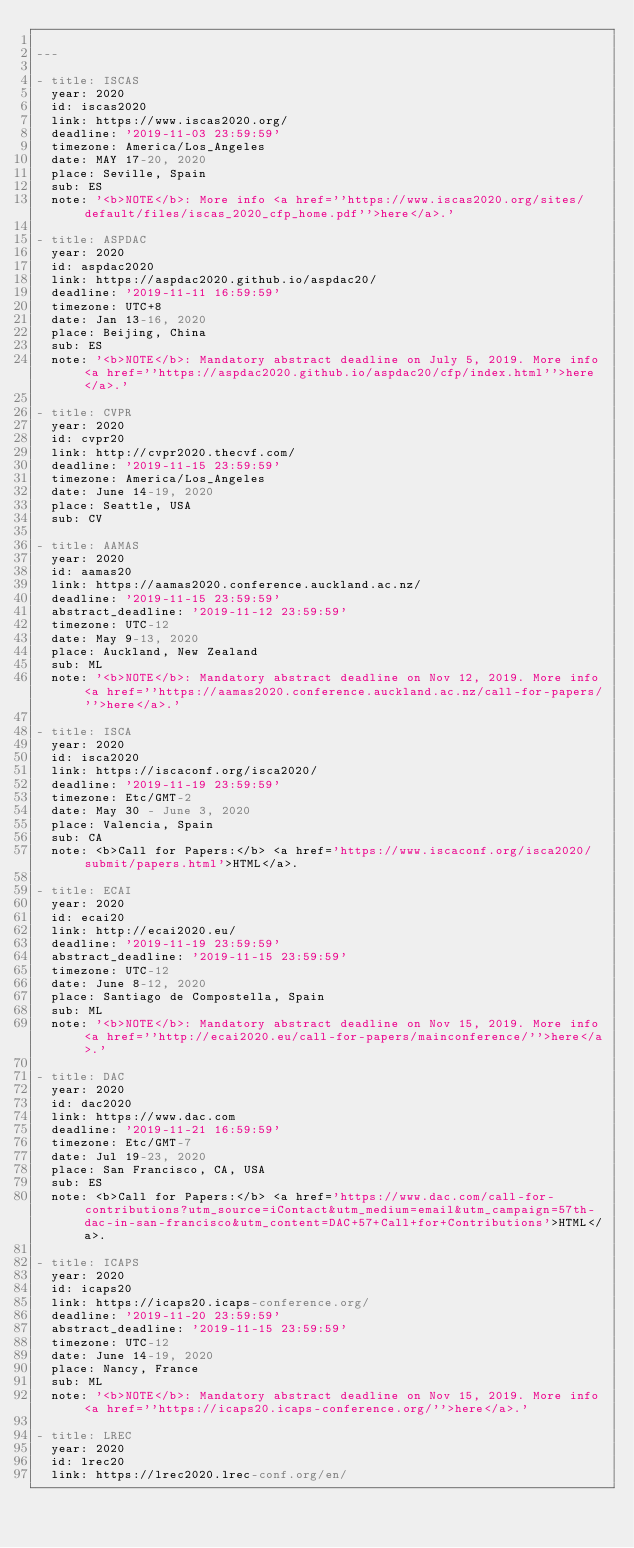Convert code to text. <code><loc_0><loc_0><loc_500><loc_500><_YAML_>
---

- title: ISCAS
  year: 2020
  id: iscas2020
  link: https://www.iscas2020.org/
  deadline: '2019-11-03 23:59:59'
  timezone: America/Los_Angeles
  date: MAY 17-20, 2020
  place: Seville, Spain
  sub: ES
  note: '<b>NOTE</b>: More info <a href=''https://www.iscas2020.org/sites/default/files/iscas_2020_cfp_home.pdf''>here</a>.'

- title: ASPDAC
  year: 2020
  id: aspdac2020
  link: https://aspdac2020.github.io/aspdac20/
  deadline: '2019-11-11 16:59:59'
  timezone: UTC+8
  date: Jan 13-16, 2020
  place: Beijing, China
  sub: ES
  note: '<b>NOTE</b>: Mandatory abstract deadline on July 5, 2019. More info <a href=''https://aspdac2020.github.io/aspdac20/cfp/index.html''>here</a>.'

- title: CVPR
  year: 2020
  id: cvpr20
  link: http://cvpr2020.thecvf.com/
  deadline: '2019-11-15 23:59:59'
  timezone: America/Los_Angeles
  date: June 14-19, 2020
  place: Seattle, USA
  sub: CV

- title: AAMAS
  year: 2020
  id: aamas20
  link: https://aamas2020.conference.auckland.ac.nz/
  deadline: '2019-11-15 23:59:59'
  abstract_deadline: '2019-11-12 23:59:59'
  timezone: UTC-12
  date: May 9-13, 2020
  place: Auckland, New Zealand
  sub: ML
  note: '<b>NOTE</b>: Mandatory abstract deadline on Nov 12, 2019. More info <a href=''https://aamas2020.conference.auckland.ac.nz/call-for-papers/''>here</a>.'

- title: ISCA
  year: 2020
  id: isca2020
  link: https://iscaconf.org/isca2020/
  deadline: '2019-11-19 23:59:59'
  timezone: Etc/GMT-2
  date: May 30 - June 3, 2020
  place: Valencia, Spain
  sub: CA
  note: <b>Call for Papers:</b> <a href='https://www.iscaconf.org/isca2020/submit/papers.html'>HTML</a>.

- title: ECAI
  year: 2020
  id: ecai20
  link: http://ecai2020.eu/
  deadline: '2019-11-19 23:59:59'
  abstract_deadline: '2019-11-15 23:59:59'
  timezone: UTC-12
  date: June 8-12, 2020
  place: Santiago de Compostella, Spain
  sub: ML
  note: '<b>NOTE</b>: Mandatory abstract deadline on Nov 15, 2019. More info <a href=''http://ecai2020.eu/call-for-papers/mainconference/''>here</a>.'

- title: DAC
  year: 2020
  id: dac2020
  link: https://www.dac.com
  deadline: '2019-11-21 16:59:59'
  timezone: Etc/GMT-7
  date: Jul 19-23, 2020
  place: San Francisco, CA, USA
  sub: ES
  note: <b>Call for Papers:</b> <a href='https://www.dac.com/call-for-contributions?utm_source=iContact&utm_medium=email&utm_campaign=57th-dac-in-san-francisco&utm_content=DAC+57+Call+for+Contributions'>HTML</a>.

- title: ICAPS
  year: 2020
  id: icaps20
  link: https://icaps20.icaps-conference.org/
  deadline: '2019-11-20 23:59:59'
  abstract_deadline: '2019-11-15 23:59:59'
  timezone: UTC-12
  date: June 14-19, 2020
  place: Nancy, France
  sub: ML
  note: '<b>NOTE</b>: Mandatory abstract deadline on Nov 15, 2019. More info <a href=''https://icaps20.icaps-conference.org/''>here</a>.'

- title: LREC
  year: 2020
  id: lrec20
  link: https://lrec2020.lrec-conf.org/en/</code> 